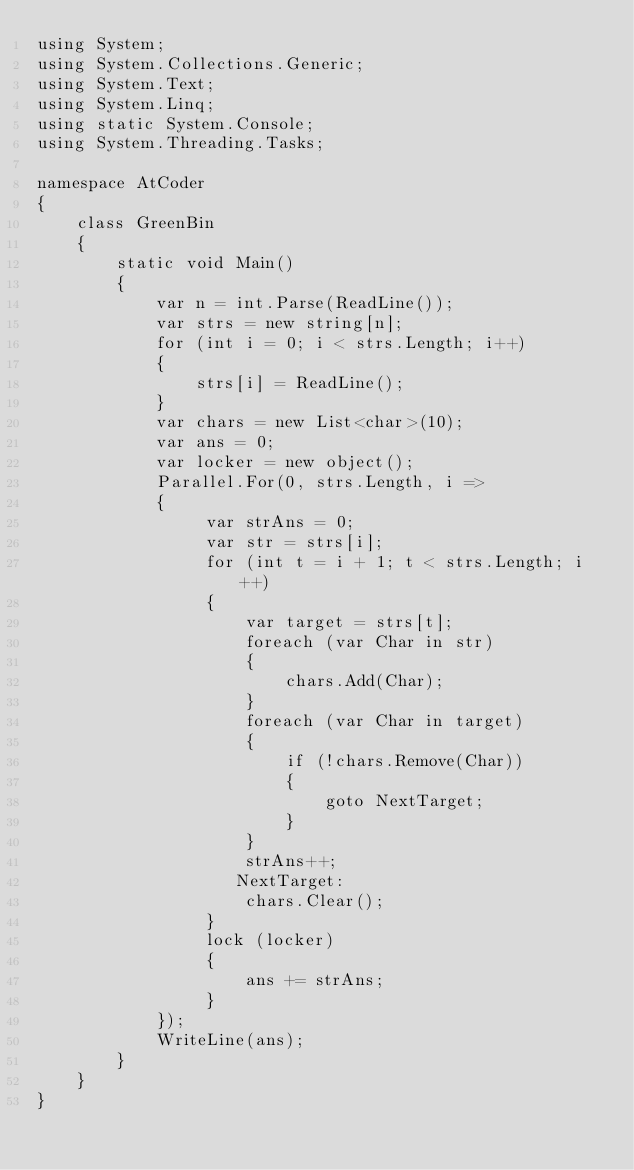<code> <loc_0><loc_0><loc_500><loc_500><_C#_>using System;
using System.Collections.Generic;
using System.Text;
using System.Linq;
using static System.Console;
using System.Threading.Tasks;

namespace AtCoder
{
    class GreenBin
    {
        static void Main()
        {
            var n = int.Parse(ReadLine());
            var strs = new string[n];
            for (int i = 0; i < strs.Length; i++)
            {
                strs[i] = ReadLine();
            }
            var chars = new List<char>(10);
            var ans = 0;
            var locker = new object();
            Parallel.For(0, strs.Length, i =>
            {
                 var strAns = 0;
                 var str = strs[i];
                 for (int t = i + 1; t < strs.Length; i++)
                 {
                     var target = strs[t];
                     foreach (var Char in str)
                     {
                         chars.Add(Char);
                     }
                     foreach (var Char in target)
                     {
                         if (!chars.Remove(Char))
                         {
                             goto NextTarget;
                         }
                     }
                     strAns++;
                    NextTarget:
                     chars.Clear();
                 }
                 lock (locker)
                 {
                     ans += strAns;
                 }
            });
            WriteLine(ans);
        }
    }
}
</code> 